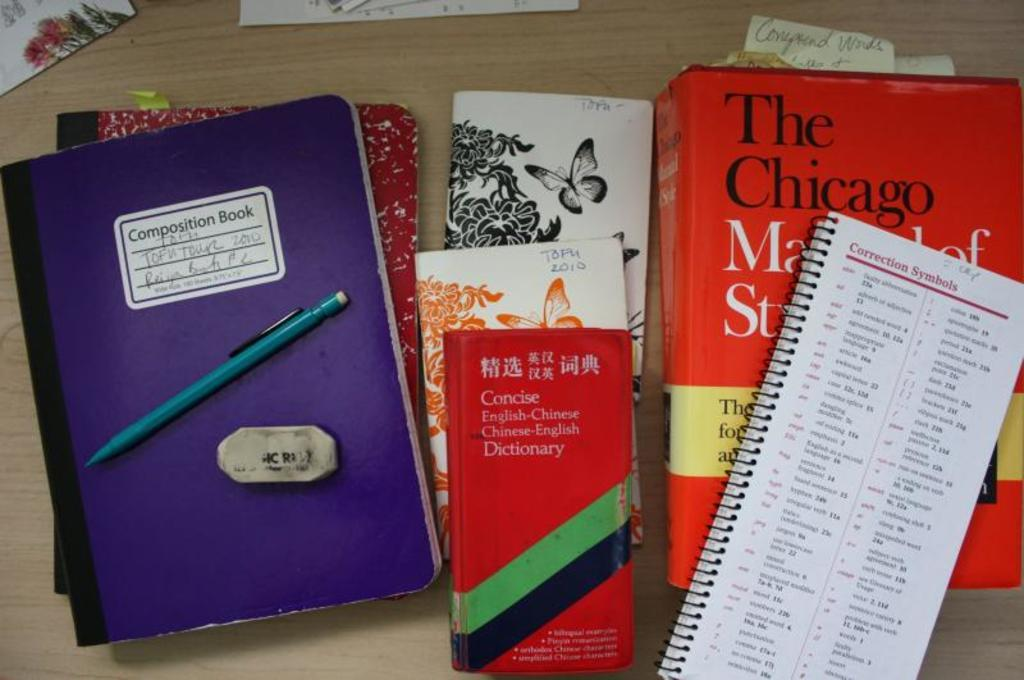What type of objects can be seen in the image? There are books, papers, and a pencil in the image. What surface are these objects placed on? There is a table in the image. What disease is the person in the image suffering from? There is no person present in the image, so it is not possible to determine if they are suffering from any disease. 